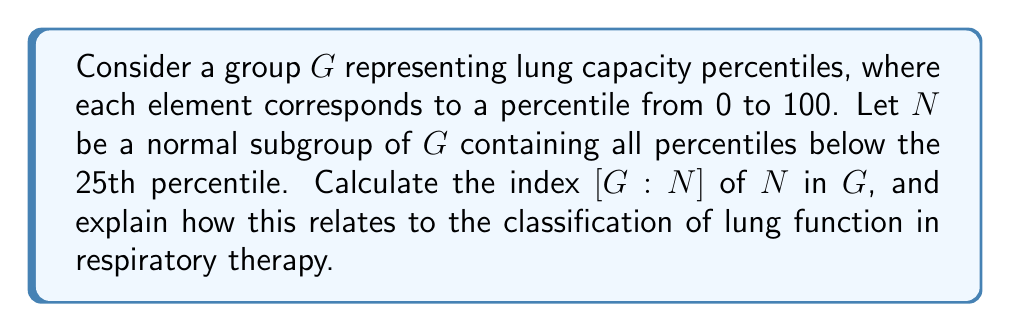Teach me how to tackle this problem. To solve this problem, we need to follow these steps:

1) First, recall that the index of a subgroup $N$ in a group $G$, denoted $[G:N]$, is the number of distinct cosets of $N$ in $G$. It's also equal to the order of $G$ divided by the order of $N$:

   $$[G:N] = \frac{|G|}{|N|}$$

2) In our case, $G$ represents all lung capacity percentiles from 0 to 100. Therefore, $|G| = 101$ (including both 0 and 100).

3) The subgroup $N$ contains all percentiles below the 25th percentile. This means $N$ includes percentiles from 0 to 24, so $|N| = 25$.

4) We can now calculate the index:

   $$[G:N] = \frac{|G|}{|N|} = \frac{101}{25} = 4.04$$

5) Since the index must be a whole number, we round down to 4.

In respiratory therapy, this result can be interpreted as follows:

- The group $G$ is divided into 4 distinct cosets by $N$.
- These cosets roughly correspond to common lung function classifications:
  1. Below 25th percentile (represented by $N$): Severely reduced lung function
  2. 25th to 50th percentile: Moderately reduced lung function
  3. 50th to 75th percentile: Mildly reduced to normal lung function
  4. Above 75th percentile: Above average lung function

This grouping aligns with how respiratory therapists and pulmonologists often categorize patients' lung capacities for treatment planning and prognosis.
Answer: The index $[G:N] = 4$ 